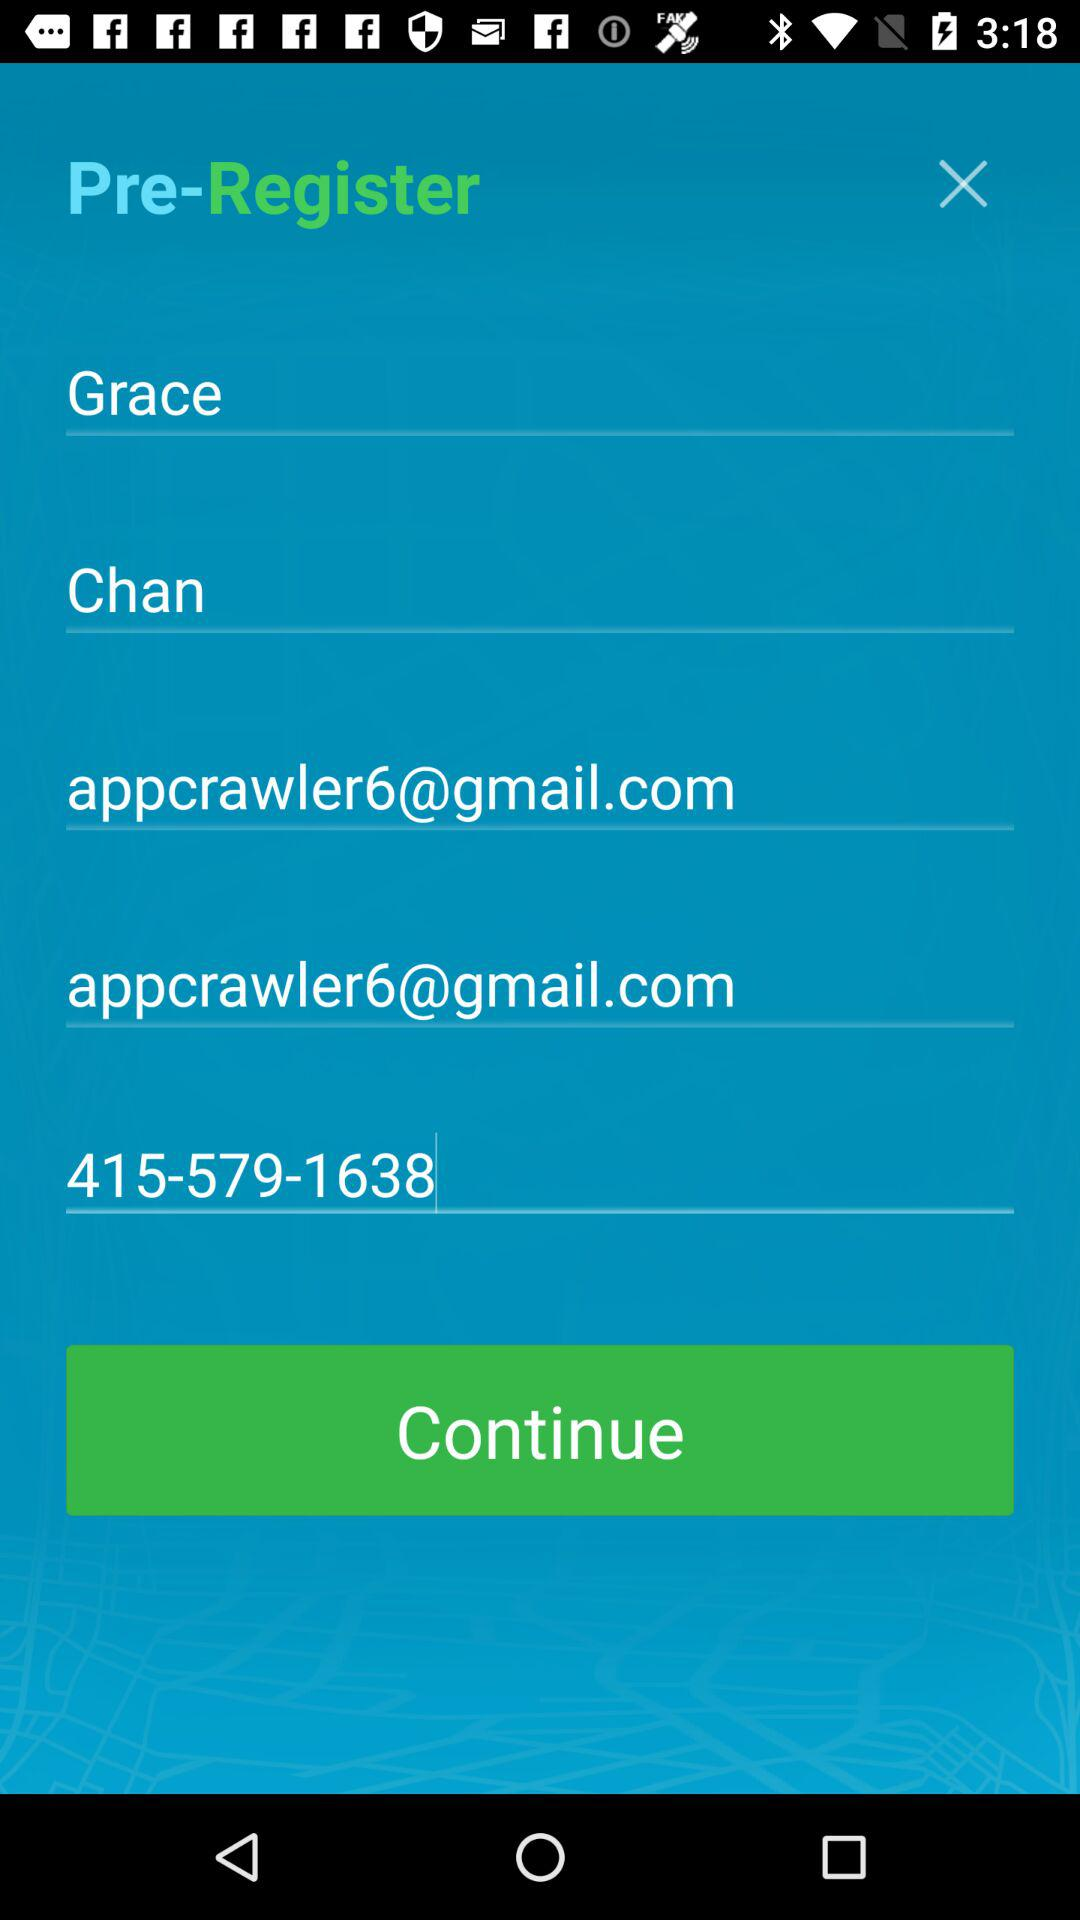How old is the user?
When the provided information is insufficient, respond with <no answer>. <no answer> 